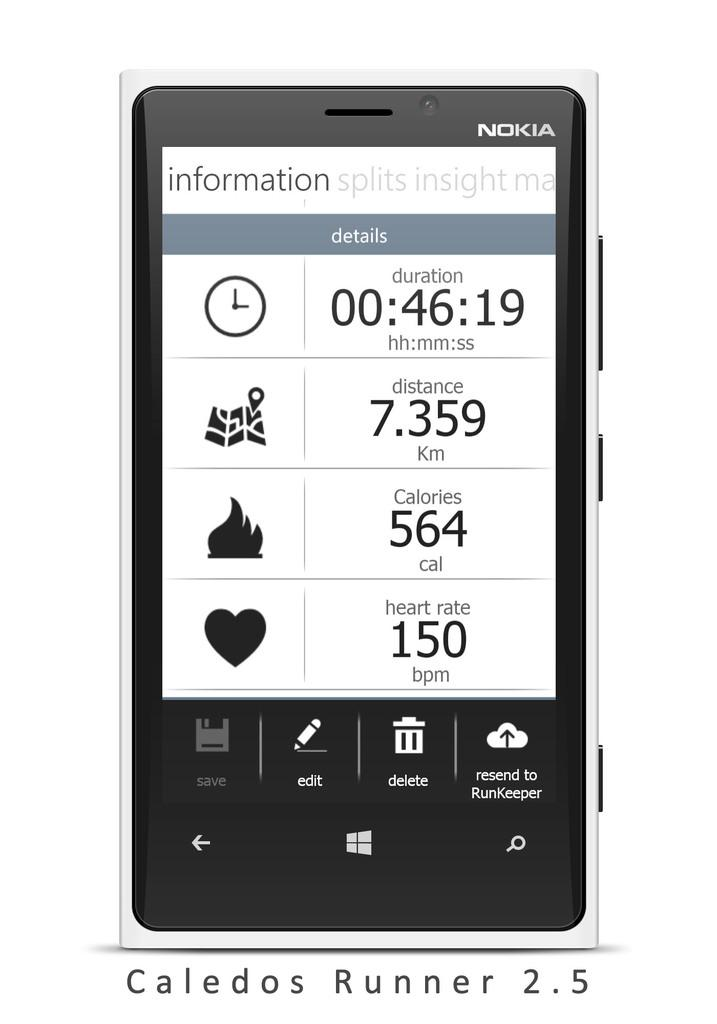<image>
Render a clear and concise summary of the photo. A Nokia Caldos Runner 2.5 is shown with the information screen displayed. 